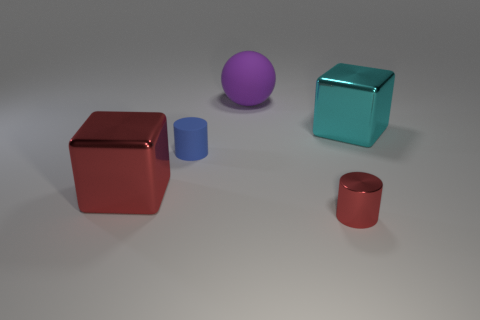What number of objects are blocks or red things?
Provide a succinct answer. 3. Is there any other thing that is made of the same material as the small red cylinder?
Provide a succinct answer. Yes. Are there any purple objects?
Your answer should be very brief. Yes. Are the tiny cylinder that is in front of the large red shiny cube and the large red thing made of the same material?
Make the answer very short. Yes. Is there a small metallic object of the same shape as the small rubber thing?
Provide a succinct answer. Yes. Is the number of metal cylinders that are behind the purple thing the same as the number of cyan metal cubes?
Provide a succinct answer. No. The large cube right of the big block that is left of the large cyan cube is made of what material?
Offer a very short reply. Metal. There is a tiny shiny object; what shape is it?
Your answer should be compact. Cylinder. Is the number of tiny things that are behind the blue thing the same as the number of things that are to the right of the small red metallic object?
Offer a terse response. No. Do the tiny object that is right of the large matte object and the large metallic object that is to the left of the small blue cylinder have the same color?
Your answer should be compact. Yes. 